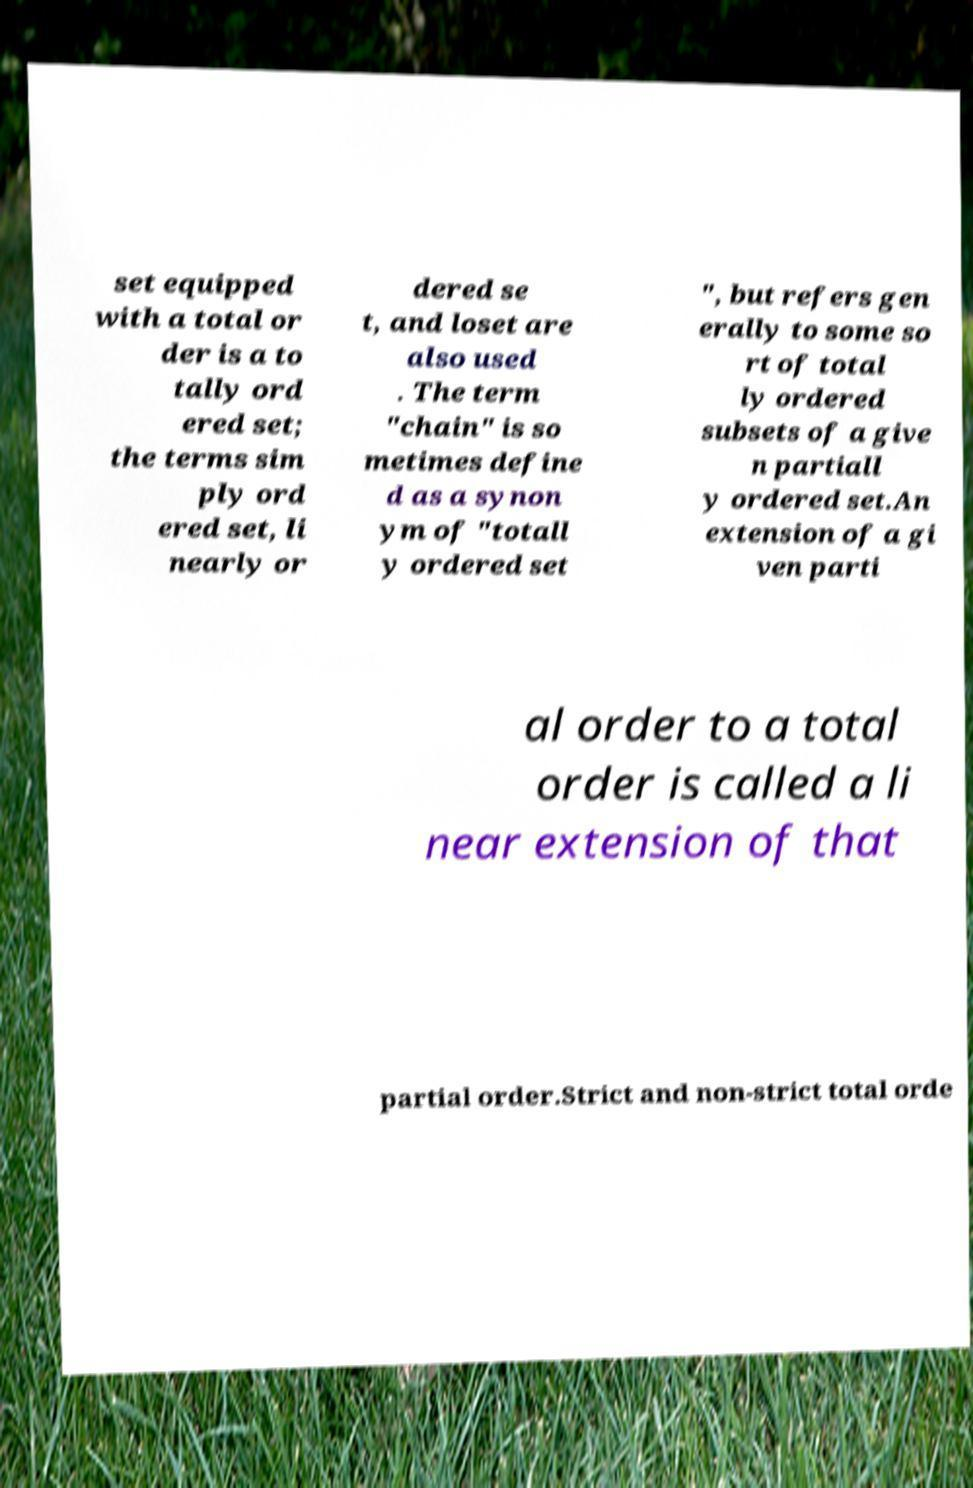Could you extract and type out the text from this image? set equipped with a total or der is a to tally ord ered set; the terms sim ply ord ered set, li nearly or dered se t, and loset are also used . The term "chain" is so metimes define d as a synon ym of "totall y ordered set ", but refers gen erally to some so rt of total ly ordered subsets of a give n partiall y ordered set.An extension of a gi ven parti al order to a total order is called a li near extension of that partial order.Strict and non-strict total orde 